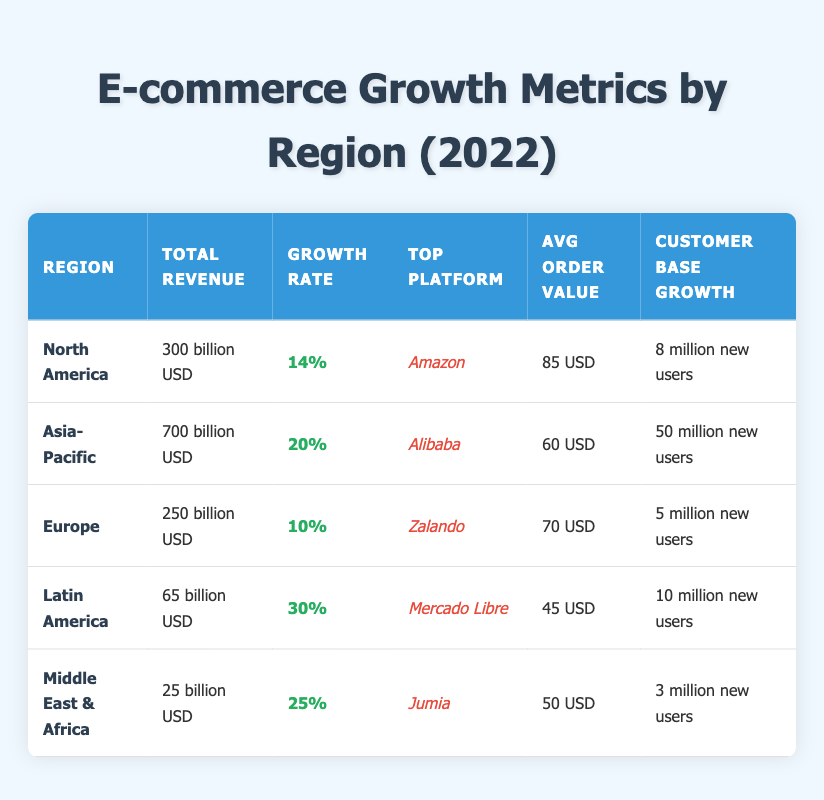What is the total revenue for the Asia-Pacific region? The total revenue for the Asia-Pacific region is clearly listed in the table as "700 billion USD."
Answer: 700 billion USD Which region has the highest growth rate? Latin America shows a growth rate of 30%, which is the highest among all the regions listed in the table.
Answer: Latin America What is the average order value in North America? The table shows that the average order value in North America is "85 USD."
Answer: 85 USD How many new customers did Europe gain? The table states that Europe gained "5 million new users," which is the value we are looking for.
Answer: 5 million new users Which region has a total revenue that is lower than 100 billion USD? The only region with a total revenue below 100 billion USD is the Middle East & Africa, which has "25 billion USD."
Answer: Middle East & Africa If we sum the new users from all regions, how many new users were there in total? By adding the new users: 8M (North America) + 50M (Asia-Pacific) + 5M (Europe) + 10M (Latin America) + 3M (Middle East & Africa), the total is 76 million new users.
Answer: 76 million new users Is the top platform in Europe the same as that in North America? The top platform in Europe is Zalando, while in North America it is Amazon; therefore, they are not the same.
Answer: No Which region had the lowest total revenue? Middle East & Africa had the lowest total revenue, listed at "25 billion USD" compared to other regions.
Answer: Middle East & Africa What is the difference in average order value between Latin America and Asia-Pacific? The average order values are 45 USD (Latin America) and 60 USD (Asia-Pacific); calculating the difference: 60 - 45 = 15 USD.
Answer: 15 USD If we consider the growth rates, how many regions exceeded a growth rate of 20%? The growth rates over 20% belong to Latin America (30%) and Middle East & Africa (25%), making it two regions in total.
Answer: 2 regions 